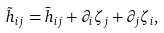Convert formula to latex. <formula><loc_0><loc_0><loc_500><loc_500>\tilde { h } _ { i j } = \bar { h } _ { i j } + \partial _ { i } \zeta _ { j } + \partial _ { j } \zeta _ { i } ,</formula> 